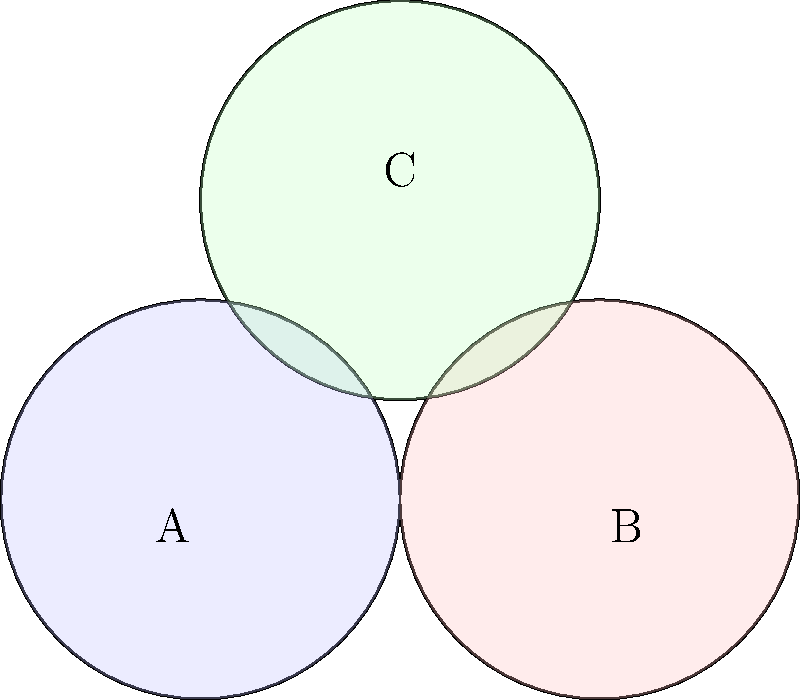In a dependency graph of shared libraries for an executable file, three circular sections represent different libraries. The centers of these circles form an equilateral triangle with side length 4 units, and each circle has a radius of 2 units. Calculate the total area of the region where all three circles overlap. To solve this problem, we'll follow these steps:

1) First, we need to find the area of the equilateral triangle formed by the centers of the circles. The height of this triangle is:

   $$h = \sqrt{4^2 - 2^2} = \sqrt{12} = 2\sqrt{3}$$

2) The area of the triangle is:

   $$A_t = \frac{1}{2} \cdot 4 \cdot 2\sqrt{3} = 4\sqrt{3}$$

3) Now, we need to find the area of the circular segment in each corner of the triangle. The central angle of this segment is 60°, or $\frac{\pi}{3}$ radians.

4) The area of a circular segment with central angle $\theta$ and radius $r$ is given by:

   $$A_s = r^2 (\theta - \sin\theta)$$

5) Substituting our values:

   $$A_s = 2^2 (\frac{\pi}{3} - \sin\frac{\pi}{3}) = 4(\frac{\pi}{3} - \frac{\sqrt{3}}{2})$$

6) The area we're looking for is the area of the triangle minus three times the area of the circular segment:

   $$A = A_t - 3A_s = 4\sqrt{3} - 12(\frac{\pi}{3} - \frac{\sqrt{3}}{2})$$

7) Simplifying:

   $$A = 4\sqrt{3} - 4\pi + 6\sqrt{3} = 10\sqrt{3} - 4\pi$$

Therefore, the area of overlap is $10\sqrt{3} - 4\pi$ square units.
Answer: $10\sqrt{3} - 4\pi$ square units 